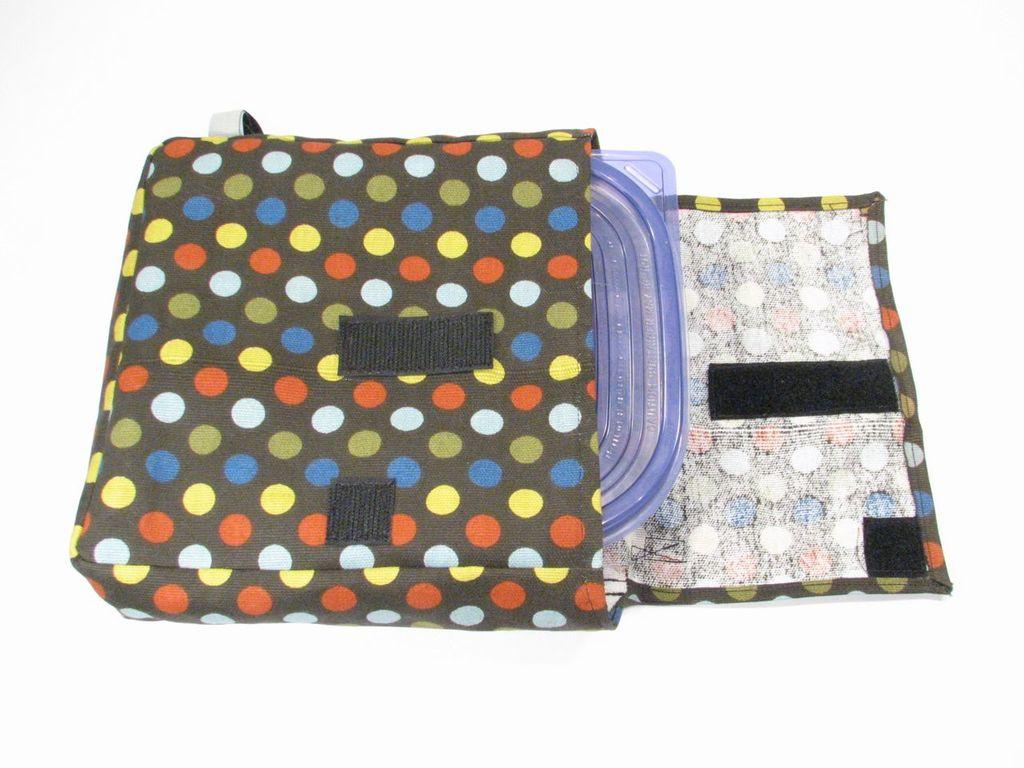What type of object is in the image? There is a plastic object in the image. Where is the plastic object located? The plastic object is in a bag. What type of plants can be seen growing in the fifth layer of the image? There are no plants present in the image, and the concept of layers does not apply to this image. 